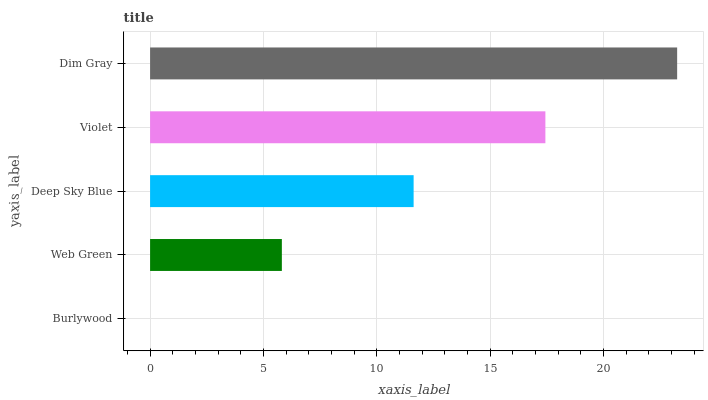Is Burlywood the minimum?
Answer yes or no. Yes. Is Dim Gray the maximum?
Answer yes or no. Yes. Is Web Green the minimum?
Answer yes or no. No. Is Web Green the maximum?
Answer yes or no. No. Is Web Green greater than Burlywood?
Answer yes or no. Yes. Is Burlywood less than Web Green?
Answer yes or no. Yes. Is Burlywood greater than Web Green?
Answer yes or no. No. Is Web Green less than Burlywood?
Answer yes or no. No. Is Deep Sky Blue the high median?
Answer yes or no. Yes. Is Deep Sky Blue the low median?
Answer yes or no. Yes. Is Web Green the high median?
Answer yes or no. No. Is Violet the low median?
Answer yes or no. No. 